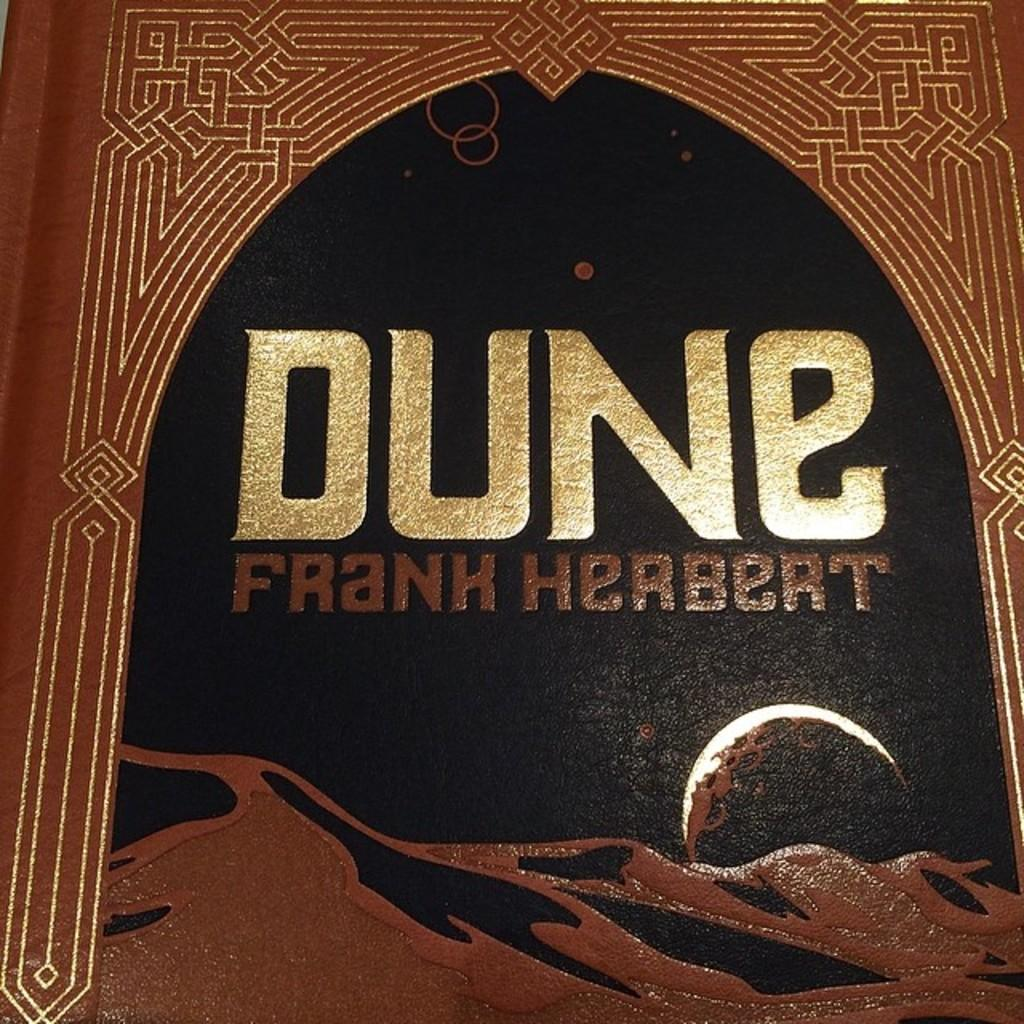What object can be seen in the image? There is a book in the image. What is on the book? There is text on the book. Where is the rabbit hiding in the image? There is no rabbit present in the image. What type of coil is wrapped around the book in the image? There is no coil present in the image. 